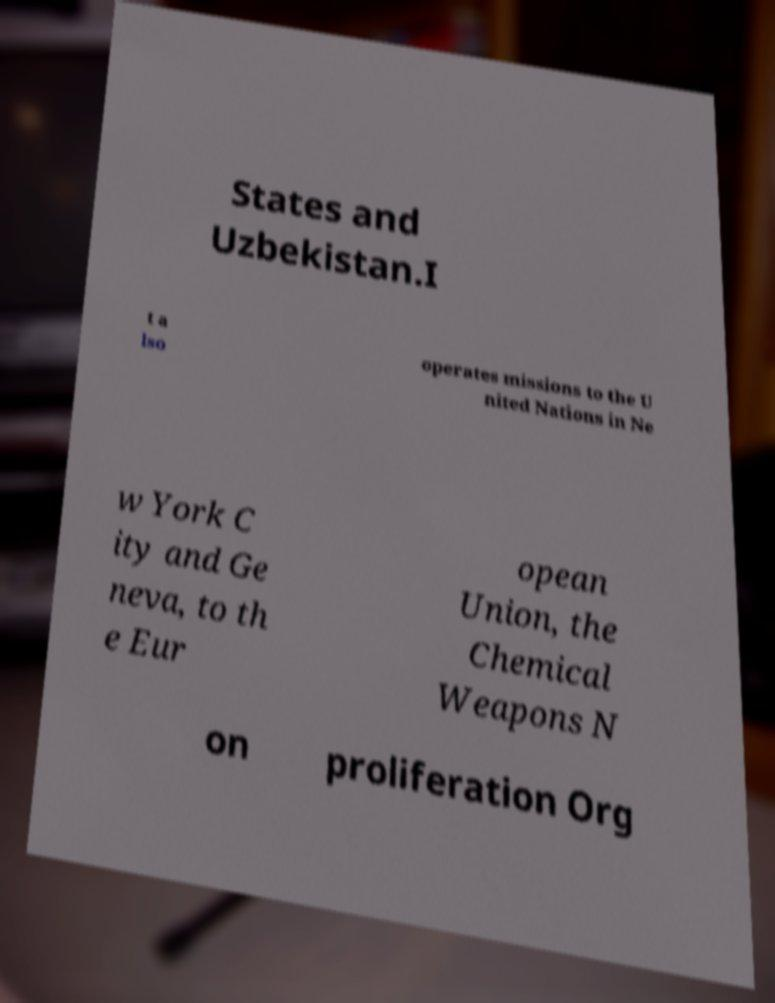For documentation purposes, I need the text within this image transcribed. Could you provide that? States and Uzbekistan.I t a lso operates missions to the U nited Nations in Ne w York C ity and Ge neva, to th e Eur opean Union, the Chemical Weapons N on proliferation Org 